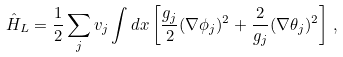<formula> <loc_0><loc_0><loc_500><loc_500>\hat { H } _ { L } = \frac { 1 } { 2 } \sum _ { j } v _ { j } \int d x \left [ \frac { g _ { j } } { 2 } ( \nabla \phi _ { j } ) ^ { 2 } + \frac { 2 } { g _ { j } } ( \nabla \theta _ { j } ) ^ { 2 } \right ] \, ,</formula> 